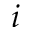Convert formula to latex. <formula><loc_0><loc_0><loc_500><loc_500>i</formula> 